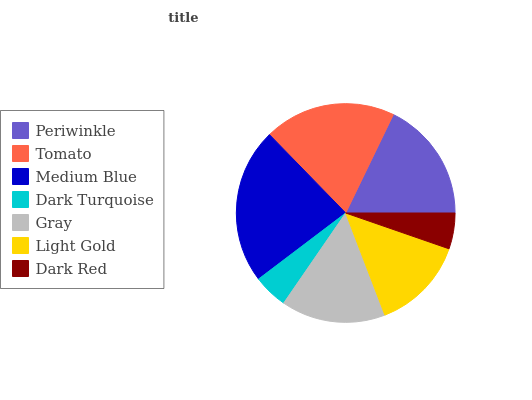Is Dark Turquoise the minimum?
Answer yes or no. Yes. Is Medium Blue the maximum?
Answer yes or no. Yes. Is Tomato the minimum?
Answer yes or no. No. Is Tomato the maximum?
Answer yes or no. No. Is Tomato greater than Periwinkle?
Answer yes or no. Yes. Is Periwinkle less than Tomato?
Answer yes or no. Yes. Is Periwinkle greater than Tomato?
Answer yes or no. No. Is Tomato less than Periwinkle?
Answer yes or no. No. Is Gray the high median?
Answer yes or no. Yes. Is Gray the low median?
Answer yes or no. Yes. Is Light Gold the high median?
Answer yes or no. No. Is Light Gold the low median?
Answer yes or no. No. 